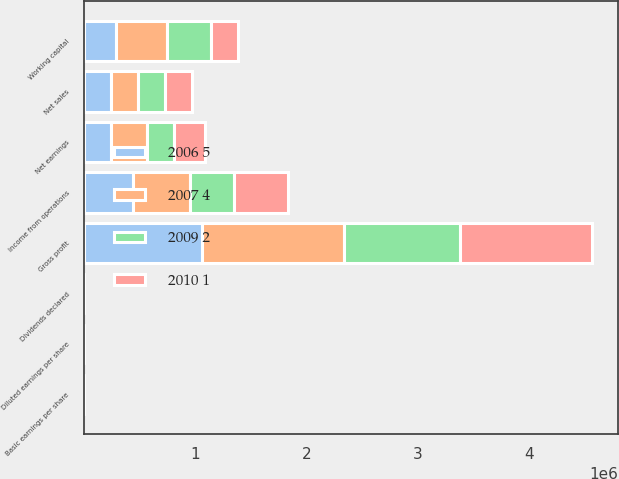<chart> <loc_0><loc_0><loc_500><loc_500><stacked_bar_chart><ecel><fcel>Net sales<fcel>Gross profit<fcel>Income from operations<fcel>Net earnings<fcel>Basic earnings per share<fcel>Diluted earnings per share<fcel>Dividends declared<fcel>Working capital<nl><fcel>2007 4<fcel>242593<fcel>1.27513e+06<fcel>514294<fcel>322580<fcel>3.42<fcel>3.34<fcel>0.4<fcel>458446<nl><fcel>2009 2<fcel>242593<fcel>1.04314e+06<fcel>395396<fcel>239481<fcel>2.64<fcel>2.58<fcel>0.34<fcel>392734<nl><fcel>2010 1<fcel>242593<fcel>1.18829e+06<fcel>486161<fcel>281874<fcel>3.15<fcel>3.01<fcel>0.3<fcel>239400<nl><fcel>2006 5<fcel>242593<fcel>1.0584e+06<fcel>438354<fcel>245705<fcel>2.78<fcel>2.64<fcel>0.27<fcel>291047<nl></chart> 